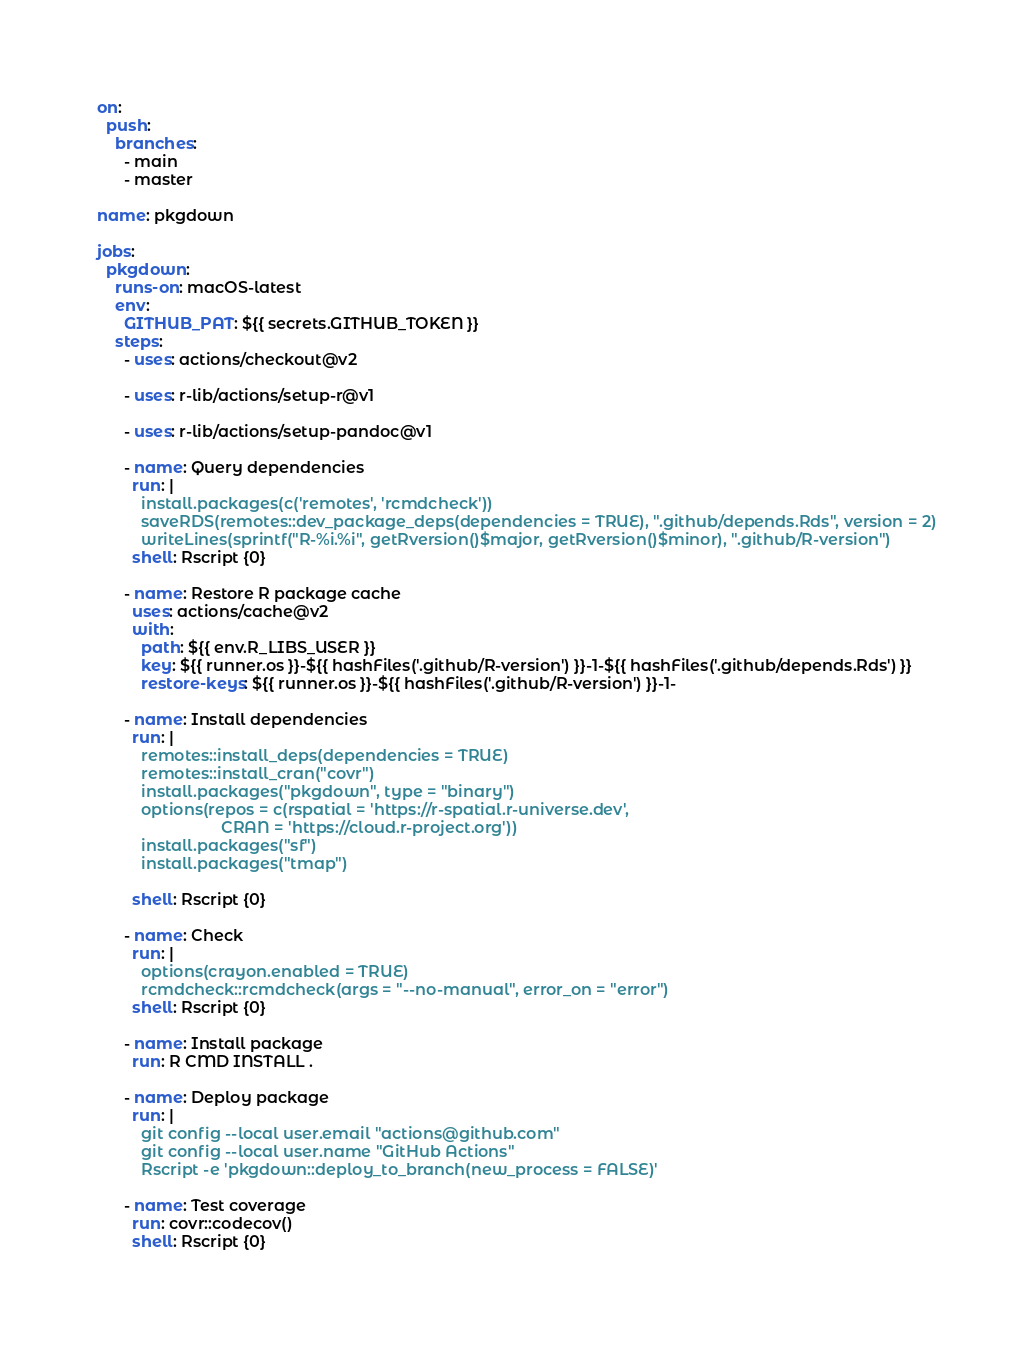<code> <loc_0><loc_0><loc_500><loc_500><_YAML_>on:
  push:
    branches:
      - main
      - master

name: pkgdown

jobs:
  pkgdown:
    runs-on: macOS-latest
    env:
      GITHUB_PAT: ${{ secrets.GITHUB_TOKEN }}
    steps:
      - uses: actions/checkout@v2

      - uses: r-lib/actions/setup-r@v1

      - uses: r-lib/actions/setup-pandoc@v1

      - name: Query dependencies
        run: |
          install.packages(c('remotes', 'rcmdcheck'))
          saveRDS(remotes::dev_package_deps(dependencies = TRUE), ".github/depends.Rds", version = 2)
          writeLines(sprintf("R-%i.%i", getRversion()$major, getRversion()$minor), ".github/R-version")
        shell: Rscript {0}

      - name: Restore R package cache
        uses: actions/cache@v2
        with:
          path: ${{ env.R_LIBS_USER }}
          key: ${{ runner.os }}-${{ hashFiles('.github/R-version') }}-1-${{ hashFiles('.github/depends.Rds') }}
          restore-keys: ${{ runner.os }}-${{ hashFiles('.github/R-version') }}-1-

      - name: Install dependencies
        run: |
          remotes::install_deps(dependencies = TRUE)
          remotes::install_cran("covr")
          install.packages("pkgdown", type = "binary")
          options(repos = c(rspatial = 'https://r-spatial.r-universe.dev',
                            CRAN = 'https://cloud.r-project.org'))
          install.packages("sf")
          install.packages("tmap")

        shell: Rscript {0}

      - name: Check
        run: |
          options(crayon.enabled = TRUE)
          rcmdcheck::rcmdcheck(args = "--no-manual", error_on = "error")
        shell: Rscript {0}

      - name: Install package
        run: R CMD INSTALL .

      - name: Deploy package
        run: |
          git config --local user.email "actions@github.com"
          git config --local user.name "GitHub Actions"
          Rscript -e 'pkgdown::deploy_to_branch(new_process = FALSE)'

      - name: Test coverage
        run: covr::codecov()
        shell: Rscript {0}
</code> 